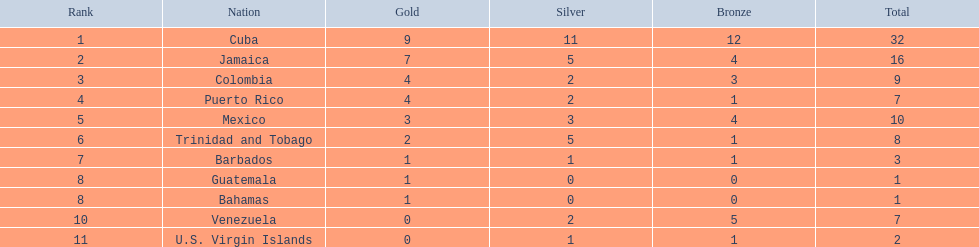Which teams won four gold medals? Colombia, Puerto Rico. From these teams, which one had only one bronze medal? Puerto Rico. 